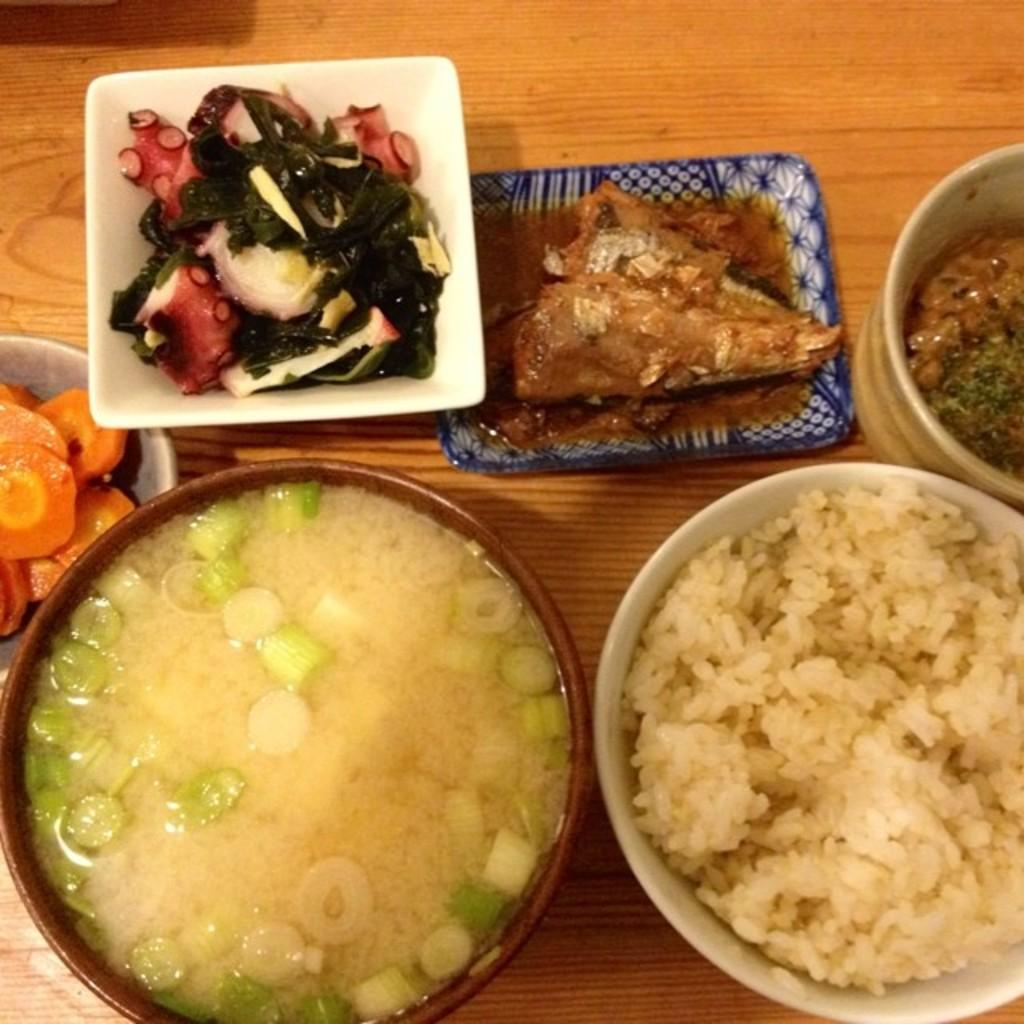What is the main piece of furniture in the image? There is a table in the image. What is placed on the table? There are bowls on the table. What can be found inside the bowls? The bowls contain different types of food items. What type of writing can be seen on the edge of the table in the image? There is no writing visible on the edge of the table in the image. 